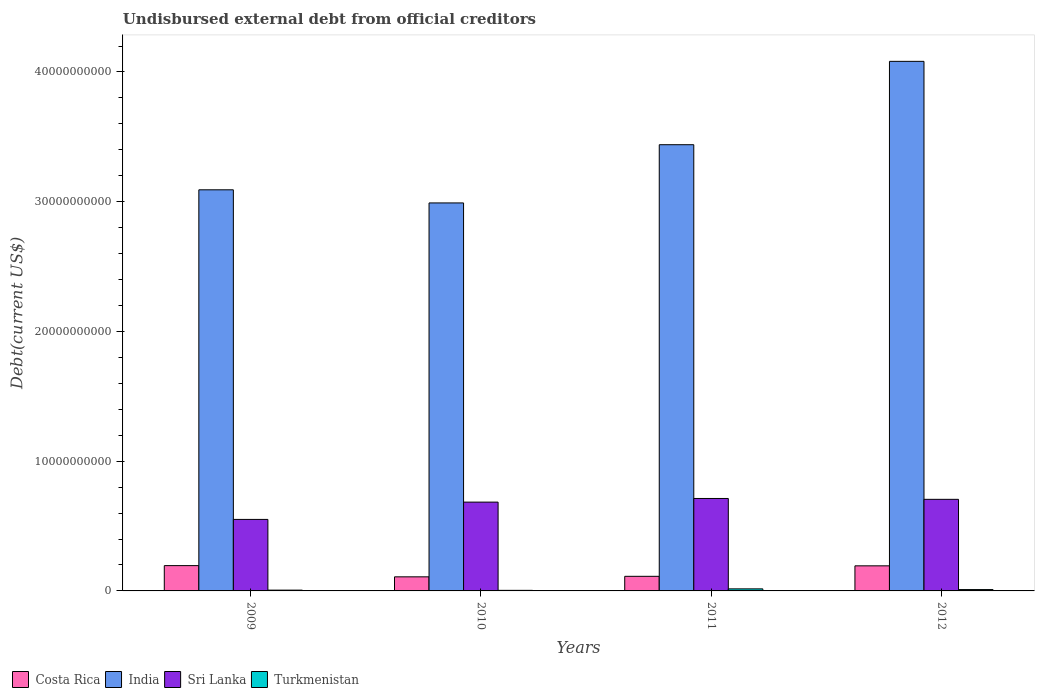How many different coloured bars are there?
Your response must be concise. 4. How many groups of bars are there?
Offer a very short reply. 4. Are the number of bars per tick equal to the number of legend labels?
Give a very brief answer. Yes. What is the label of the 1st group of bars from the left?
Give a very brief answer. 2009. What is the total debt in Sri Lanka in 2010?
Provide a short and direct response. 6.85e+09. Across all years, what is the maximum total debt in India?
Your response must be concise. 4.08e+1. Across all years, what is the minimum total debt in Sri Lanka?
Ensure brevity in your answer.  5.51e+09. In which year was the total debt in Sri Lanka maximum?
Your answer should be compact. 2011. In which year was the total debt in India minimum?
Your response must be concise. 2010. What is the total total debt in India in the graph?
Your answer should be very brief. 1.36e+11. What is the difference between the total debt in Costa Rica in 2009 and that in 2010?
Provide a succinct answer. 8.65e+08. What is the difference between the total debt in Sri Lanka in 2011 and the total debt in Turkmenistan in 2010?
Offer a very short reply. 7.08e+09. What is the average total debt in India per year?
Offer a terse response. 3.40e+1. In the year 2011, what is the difference between the total debt in Costa Rica and total debt in Sri Lanka?
Keep it short and to the point. -6.00e+09. What is the ratio of the total debt in India in 2010 to that in 2012?
Offer a very short reply. 0.73. Is the total debt in Costa Rica in 2011 less than that in 2012?
Provide a succinct answer. Yes. Is the difference between the total debt in Costa Rica in 2009 and 2012 greater than the difference between the total debt in Sri Lanka in 2009 and 2012?
Offer a terse response. Yes. What is the difference between the highest and the second highest total debt in Sri Lanka?
Keep it short and to the point. 6.60e+07. What is the difference between the highest and the lowest total debt in Costa Rica?
Make the answer very short. 8.65e+08. Is the sum of the total debt in Sri Lanka in 2009 and 2010 greater than the maximum total debt in Turkmenistan across all years?
Your response must be concise. Yes. What does the 2nd bar from the left in 2012 represents?
Provide a short and direct response. India. What does the 2nd bar from the right in 2010 represents?
Make the answer very short. Sri Lanka. How many bars are there?
Keep it short and to the point. 16. Are all the bars in the graph horizontal?
Provide a succinct answer. No. How many years are there in the graph?
Give a very brief answer. 4. Are the values on the major ticks of Y-axis written in scientific E-notation?
Offer a terse response. No. How many legend labels are there?
Your answer should be very brief. 4. What is the title of the graph?
Offer a terse response. Undisbursed external debt from official creditors. What is the label or title of the Y-axis?
Your response must be concise. Debt(current US$). What is the Debt(current US$) of Costa Rica in 2009?
Offer a terse response. 1.95e+09. What is the Debt(current US$) in India in 2009?
Your answer should be very brief. 3.09e+1. What is the Debt(current US$) of Sri Lanka in 2009?
Ensure brevity in your answer.  5.51e+09. What is the Debt(current US$) in Turkmenistan in 2009?
Make the answer very short. 6.07e+07. What is the Debt(current US$) of Costa Rica in 2010?
Your answer should be compact. 1.09e+09. What is the Debt(current US$) in India in 2010?
Offer a terse response. 2.99e+1. What is the Debt(current US$) of Sri Lanka in 2010?
Your response must be concise. 6.85e+09. What is the Debt(current US$) in Turkmenistan in 2010?
Your response must be concise. 4.42e+07. What is the Debt(current US$) of Costa Rica in 2011?
Ensure brevity in your answer.  1.12e+09. What is the Debt(current US$) of India in 2011?
Your answer should be very brief. 3.44e+1. What is the Debt(current US$) in Sri Lanka in 2011?
Offer a terse response. 7.13e+09. What is the Debt(current US$) in Turkmenistan in 2011?
Provide a succinct answer. 1.58e+08. What is the Debt(current US$) in Costa Rica in 2012?
Give a very brief answer. 1.93e+09. What is the Debt(current US$) in India in 2012?
Offer a terse response. 4.08e+1. What is the Debt(current US$) in Sri Lanka in 2012?
Keep it short and to the point. 7.06e+09. What is the Debt(current US$) in Turkmenistan in 2012?
Offer a very short reply. 1.04e+08. Across all years, what is the maximum Debt(current US$) of Costa Rica?
Your answer should be compact. 1.95e+09. Across all years, what is the maximum Debt(current US$) of India?
Keep it short and to the point. 4.08e+1. Across all years, what is the maximum Debt(current US$) in Sri Lanka?
Your answer should be very brief. 7.13e+09. Across all years, what is the maximum Debt(current US$) of Turkmenistan?
Your answer should be compact. 1.58e+08. Across all years, what is the minimum Debt(current US$) in Costa Rica?
Keep it short and to the point. 1.09e+09. Across all years, what is the minimum Debt(current US$) in India?
Provide a succinct answer. 2.99e+1. Across all years, what is the minimum Debt(current US$) of Sri Lanka?
Offer a very short reply. 5.51e+09. Across all years, what is the minimum Debt(current US$) of Turkmenistan?
Make the answer very short. 4.42e+07. What is the total Debt(current US$) in Costa Rica in the graph?
Give a very brief answer. 6.09e+09. What is the total Debt(current US$) in India in the graph?
Provide a short and direct response. 1.36e+11. What is the total Debt(current US$) in Sri Lanka in the graph?
Offer a very short reply. 2.65e+1. What is the total Debt(current US$) in Turkmenistan in the graph?
Make the answer very short. 3.67e+08. What is the difference between the Debt(current US$) of Costa Rica in 2009 and that in 2010?
Make the answer very short. 8.65e+08. What is the difference between the Debt(current US$) in India in 2009 and that in 2010?
Your answer should be compact. 1.01e+09. What is the difference between the Debt(current US$) of Sri Lanka in 2009 and that in 2010?
Provide a succinct answer. -1.33e+09. What is the difference between the Debt(current US$) in Turkmenistan in 2009 and that in 2010?
Give a very brief answer. 1.65e+07. What is the difference between the Debt(current US$) in Costa Rica in 2009 and that in 2011?
Give a very brief answer. 8.26e+08. What is the difference between the Debt(current US$) of India in 2009 and that in 2011?
Keep it short and to the point. -3.48e+09. What is the difference between the Debt(current US$) of Sri Lanka in 2009 and that in 2011?
Ensure brevity in your answer.  -1.61e+09. What is the difference between the Debt(current US$) in Turkmenistan in 2009 and that in 2011?
Make the answer very short. -9.70e+07. What is the difference between the Debt(current US$) in Costa Rica in 2009 and that in 2012?
Make the answer very short. 1.74e+07. What is the difference between the Debt(current US$) in India in 2009 and that in 2012?
Give a very brief answer. -9.90e+09. What is the difference between the Debt(current US$) of Sri Lanka in 2009 and that in 2012?
Offer a very short reply. -1.55e+09. What is the difference between the Debt(current US$) of Turkmenistan in 2009 and that in 2012?
Give a very brief answer. -4.34e+07. What is the difference between the Debt(current US$) of Costa Rica in 2010 and that in 2011?
Keep it short and to the point. -3.95e+07. What is the difference between the Debt(current US$) of India in 2010 and that in 2011?
Offer a terse response. -4.49e+09. What is the difference between the Debt(current US$) of Sri Lanka in 2010 and that in 2011?
Your answer should be very brief. -2.80e+08. What is the difference between the Debt(current US$) of Turkmenistan in 2010 and that in 2011?
Provide a succinct answer. -1.14e+08. What is the difference between the Debt(current US$) of Costa Rica in 2010 and that in 2012?
Provide a short and direct response. -8.48e+08. What is the difference between the Debt(current US$) in India in 2010 and that in 2012?
Make the answer very short. -1.09e+1. What is the difference between the Debt(current US$) in Sri Lanka in 2010 and that in 2012?
Your answer should be very brief. -2.14e+08. What is the difference between the Debt(current US$) of Turkmenistan in 2010 and that in 2012?
Ensure brevity in your answer.  -5.99e+07. What is the difference between the Debt(current US$) of Costa Rica in 2011 and that in 2012?
Keep it short and to the point. -8.08e+08. What is the difference between the Debt(current US$) of India in 2011 and that in 2012?
Your answer should be very brief. -6.43e+09. What is the difference between the Debt(current US$) in Sri Lanka in 2011 and that in 2012?
Give a very brief answer. 6.60e+07. What is the difference between the Debt(current US$) of Turkmenistan in 2011 and that in 2012?
Offer a terse response. 5.37e+07. What is the difference between the Debt(current US$) in Costa Rica in 2009 and the Debt(current US$) in India in 2010?
Offer a terse response. -2.80e+1. What is the difference between the Debt(current US$) of Costa Rica in 2009 and the Debt(current US$) of Sri Lanka in 2010?
Offer a terse response. -4.90e+09. What is the difference between the Debt(current US$) in Costa Rica in 2009 and the Debt(current US$) in Turkmenistan in 2010?
Your response must be concise. 1.91e+09. What is the difference between the Debt(current US$) of India in 2009 and the Debt(current US$) of Sri Lanka in 2010?
Your response must be concise. 2.41e+1. What is the difference between the Debt(current US$) in India in 2009 and the Debt(current US$) in Turkmenistan in 2010?
Offer a terse response. 3.09e+1. What is the difference between the Debt(current US$) in Sri Lanka in 2009 and the Debt(current US$) in Turkmenistan in 2010?
Your answer should be very brief. 5.47e+09. What is the difference between the Debt(current US$) in Costa Rica in 2009 and the Debt(current US$) in India in 2011?
Provide a succinct answer. -3.24e+1. What is the difference between the Debt(current US$) in Costa Rica in 2009 and the Debt(current US$) in Sri Lanka in 2011?
Your answer should be very brief. -5.18e+09. What is the difference between the Debt(current US$) of Costa Rica in 2009 and the Debt(current US$) of Turkmenistan in 2011?
Provide a short and direct response. 1.79e+09. What is the difference between the Debt(current US$) of India in 2009 and the Debt(current US$) of Sri Lanka in 2011?
Give a very brief answer. 2.38e+1. What is the difference between the Debt(current US$) in India in 2009 and the Debt(current US$) in Turkmenistan in 2011?
Offer a very short reply. 3.08e+1. What is the difference between the Debt(current US$) of Sri Lanka in 2009 and the Debt(current US$) of Turkmenistan in 2011?
Your response must be concise. 5.35e+09. What is the difference between the Debt(current US$) in Costa Rica in 2009 and the Debt(current US$) in India in 2012?
Make the answer very short. -3.89e+1. What is the difference between the Debt(current US$) of Costa Rica in 2009 and the Debt(current US$) of Sri Lanka in 2012?
Your response must be concise. -5.11e+09. What is the difference between the Debt(current US$) of Costa Rica in 2009 and the Debt(current US$) of Turkmenistan in 2012?
Provide a short and direct response. 1.85e+09. What is the difference between the Debt(current US$) of India in 2009 and the Debt(current US$) of Sri Lanka in 2012?
Provide a short and direct response. 2.39e+1. What is the difference between the Debt(current US$) in India in 2009 and the Debt(current US$) in Turkmenistan in 2012?
Offer a terse response. 3.08e+1. What is the difference between the Debt(current US$) of Sri Lanka in 2009 and the Debt(current US$) of Turkmenistan in 2012?
Make the answer very short. 5.41e+09. What is the difference between the Debt(current US$) in Costa Rica in 2010 and the Debt(current US$) in India in 2011?
Keep it short and to the point. -3.33e+1. What is the difference between the Debt(current US$) of Costa Rica in 2010 and the Debt(current US$) of Sri Lanka in 2011?
Provide a short and direct response. -6.04e+09. What is the difference between the Debt(current US$) of Costa Rica in 2010 and the Debt(current US$) of Turkmenistan in 2011?
Make the answer very short. 9.28e+08. What is the difference between the Debt(current US$) in India in 2010 and the Debt(current US$) in Sri Lanka in 2011?
Your answer should be compact. 2.28e+1. What is the difference between the Debt(current US$) of India in 2010 and the Debt(current US$) of Turkmenistan in 2011?
Offer a terse response. 2.97e+1. What is the difference between the Debt(current US$) in Sri Lanka in 2010 and the Debt(current US$) in Turkmenistan in 2011?
Give a very brief answer. 6.69e+09. What is the difference between the Debt(current US$) in Costa Rica in 2010 and the Debt(current US$) in India in 2012?
Provide a succinct answer. -3.97e+1. What is the difference between the Debt(current US$) in Costa Rica in 2010 and the Debt(current US$) in Sri Lanka in 2012?
Keep it short and to the point. -5.97e+09. What is the difference between the Debt(current US$) of Costa Rica in 2010 and the Debt(current US$) of Turkmenistan in 2012?
Offer a very short reply. 9.81e+08. What is the difference between the Debt(current US$) of India in 2010 and the Debt(current US$) of Sri Lanka in 2012?
Make the answer very short. 2.28e+1. What is the difference between the Debt(current US$) in India in 2010 and the Debt(current US$) in Turkmenistan in 2012?
Offer a very short reply. 2.98e+1. What is the difference between the Debt(current US$) of Sri Lanka in 2010 and the Debt(current US$) of Turkmenistan in 2012?
Your response must be concise. 6.74e+09. What is the difference between the Debt(current US$) of Costa Rica in 2011 and the Debt(current US$) of India in 2012?
Offer a terse response. -3.97e+1. What is the difference between the Debt(current US$) in Costa Rica in 2011 and the Debt(current US$) in Sri Lanka in 2012?
Your response must be concise. -5.93e+09. What is the difference between the Debt(current US$) of Costa Rica in 2011 and the Debt(current US$) of Turkmenistan in 2012?
Your response must be concise. 1.02e+09. What is the difference between the Debt(current US$) in India in 2011 and the Debt(current US$) in Sri Lanka in 2012?
Your answer should be compact. 2.73e+1. What is the difference between the Debt(current US$) of India in 2011 and the Debt(current US$) of Turkmenistan in 2012?
Offer a terse response. 3.43e+1. What is the difference between the Debt(current US$) in Sri Lanka in 2011 and the Debt(current US$) in Turkmenistan in 2012?
Your answer should be compact. 7.02e+09. What is the average Debt(current US$) in Costa Rica per year?
Your answer should be very brief. 1.52e+09. What is the average Debt(current US$) in India per year?
Provide a short and direct response. 3.40e+1. What is the average Debt(current US$) in Sri Lanka per year?
Give a very brief answer. 6.64e+09. What is the average Debt(current US$) of Turkmenistan per year?
Your response must be concise. 9.17e+07. In the year 2009, what is the difference between the Debt(current US$) in Costa Rica and Debt(current US$) in India?
Offer a terse response. -2.90e+1. In the year 2009, what is the difference between the Debt(current US$) in Costa Rica and Debt(current US$) in Sri Lanka?
Offer a terse response. -3.56e+09. In the year 2009, what is the difference between the Debt(current US$) of Costa Rica and Debt(current US$) of Turkmenistan?
Keep it short and to the point. 1.89e+09. In the year 2009, what is the difference between the Debt(current US$) of India and Debt(current US$) of Sri Lanka?
Provide a succinct answer. 2.54e+1. In the year 2009, what is the difference between the Debt(current US$) of India and Debt(current US$) of Turkmenistan?
Give a very brief answer. 3.09e+1. In the year 2009, what is the difference between the Debt(current US$) in Sri Lanka and Debt(current US$) in Turkmenistan?
Offer a very short reply. 5.45e+09. In the year 2010, what is the difference between the Debt(current US$) in Costa Rica and Debt(current US$) in India?
Your response must be concise. -2.88e+1. In the year 2010, what is the difference between the Debt(current US$) in Costa Rica and Debt(current US$) in Sri Lanka?
Your response must be concise. -5.76e+09. In the year 2010, what is the difference between the Debt(current US$) in Costa Rica and Debt(current US$) in Turkmenistan?
Keep it short and to the point. 1.04e+09. In the year 2010, what is the difference between the Debt(current US$) in India and Debt(current US$) in Sri Lanka?
Your response must be concise. 2.31e+1. In the year 2010, what is the difference between the Debt(current US$) of India and Debt(current US$) of Turkmenistan?
Ensure brevity in your answer.  2.99e+1. In the year 2010, what is the difference between the Debt(current US$) in Sri Lanka and Debt(current US$) in Turkmenistan?
Offer a terse response. 6.80e+09. In the year 2011, what is the difference between the Debt(current US$) of Costa Rica and Debt(current US$) of India?
Provide a succinct answer. -3.33e+1. In the year 2011, what is the difference between the Debt(current US$) of Costa Rica and Debt(current US$) of Sri Lanka?
Provide a short and direct response. -6.00e+09. In the year 2011, what is the difference between the Debt(current US$) of Costa Rica and Debt(current US$) of Turkmenistan?
Offer a terse response. 9.67e+08. In the year 2011, what is the difference between the Debt(current US$) of India and Debt(current US$) of Sri Lanka?
Your response must be concise. 2.73e+1. In the year 2011, what is the difference between the Debt(current US$) in India and Debt(current US$) in Turkmenistan?
Provide a succinct answer. 3.42e+1. In the year 2011, what is the difference between the Debt(current US$) of Sri Lanka and Debt(current US$) of Turkmenistan?
Offer a very short reply. 6.97e+09. In the year 2012, what is the difference between the Debt(current US$) in Costa Rica and Debt(current US$) in India?
Offer a terse response. -3.89e+1. In the year 2012, what is the difference between the Debt(current US$) of Costa Rica and Debt(current US$) of Sri Lanka?
Offer a very short reply. -5.13e+09. In the year 2012, what is the difference between the Debt(current US$) of Costa Rica and Debt(current US$) of Turkmenistan?
Offer a very short reply. 1.83e+09. In the year 2012, what is the difference between the Debt(current US$) of India and Debt(current US$) of Sri Lanka?
Your answer should be compact. 3.38e+1. In the year 2012, what is the difference between the Debt(current US$) of India and Debt(current US$) of Turkmenistan?
Provide a succinct answer. 4.07e+1. In the year 2012, what is the difference between the Debt(current US$) of Sri Lanka and Debt(current US$) of Turkmenistan?
Make the answer very short. 6.96e+09. What is the ratio of the Debt(current US$) in Costa Rica in 2009 to that in 2010?
Your response must be concise. 1.8. What is the ratio of the Debt(current US$) in India in 2009 to that in 2010?
Provide a succinct answer. 1.03. What is the ratio of the Debt(current US$) of Sri Lanka in 2009 to that in 2010?
Keep it short and to the point. 0.81. What is the ratio of the Debt(current US$) of Turkmenistan in 2009 to that in 2010?
Offer a very short reply. 1.37. What is the ratio of the Debt(current US$) in Costa Rica in 2009 to that in 2011?
Make the answer very short. 1.73. What is the ratio of the Debt(current US$) in India in 2009 to that in 2011?
Your response must be concise. 0.9. What is the ratio of the Debt(current US$) in Sri Lanka in 2009 to that in 2011?
Make the answer very short. 0.77. What is the ratio of the Debt(current US$) in Turkmenistan in 2009 to that in 2011?
Give a very brief answer. 0.38. What is the ratio of the Debt(current US$) of Costa Rica in 2009 to that in 2012?
Provide a succinct answer. 1.01. What is the ratio of the Debt(current US$) in India in 2009 to that in 2012?
Give a very brief answer. 0.76. What is the ratio of the Debt(current US$) in Sri Lanka in 2009 to that in 2012?
Offer a very short reply. 0.78. What is the ratio of the Debt(current US$) of Turkmenistan in 2009 to that in 2012?
Your answer should be compact. 0.58. What is the ratio of the Debt(current US$) of Costa Rica in 2010 to that in 2011?
Keep it short and to the point. 0.96. What is the ratio of the Debt(current US$) in India in 2010 to that in 2011?
Provide a short and direct response. 0.87. What is the ratio of the Debt(current US$) of Sri Lanka in 2010 to that in 2011?
Offer a terse response. 0.96. What is the ratio of the Debt(current US$) of Turkmenistan in 2010 to that in 2011?
Ensure brevity in your answer.  0.28. What is the ratio of the Debt(current US$) of Costa Rica in 2010 to that in 2012?
Offer a very short reply. 0.56. What is the ratio of the Debt(current US$) in India in 2010 to that in 2012?
Offer a very short reply. 0.73. What is the ratio of the Debt(current US$) in Sri Lanka in 2010 to that in 2012?
Give a very brief answer. 0.97. What is the ratio of the Debt(current US$) of Turkmenistan in 2010 to that in 2012?
Your answer should be very brief. 0.42. What is the ratio of the Debt(current US$) of Costa Rica in 2011 to that in 2012?
Ensure brevity in your answer.  0.58. What is the ratio of the Debt(current US$) of India in 2011 to that in 2012?
Offer a very short reply. 0.84. What is the ratio of the Debt(current US$) in Sri Lanka in 2011 to that in 2012?
Offer a terse response. 1.01. What is the ratio of the Debt(current US$) of Turkmenistan in 2011 to that in 2012?
Offer a terse response. 1.52. What is the difference between the highest and the second highest Debt(current US$) in Costa Rica?
Keep it short and to the point. 1.74e+07. What is the difference between the highest and the second highest Debt(current US$) of India?
Provide a succinct answer. 6.43e+09. What is the difference between the highest and the second highest Debt(current US$) of Sri Lanka?
Offer a very short reply. 6.60e+07. What is the difference between the highest and the second highest Debt(current US$) of Turkmenistan?
Your answer should be very brief. 5.37e+07. What is the difference between the highest and the lowest Debt(current US$) in Costa Rica?
Keep it short and to the point. 8.65e+08. What is the difference between the highest and the lowest Debt(current US$) in India?
Keep it short and to the point. 1.09e+1. What is the difference between the highest and the lowest Debt(current US$) in Sri Lanka?
Your answer should be very brief. 1.61e+09. What is the difference between the highest and the lowest Debt(current US$) in Turkmenistan?
Offer a very short reply. 1.14e+08. 